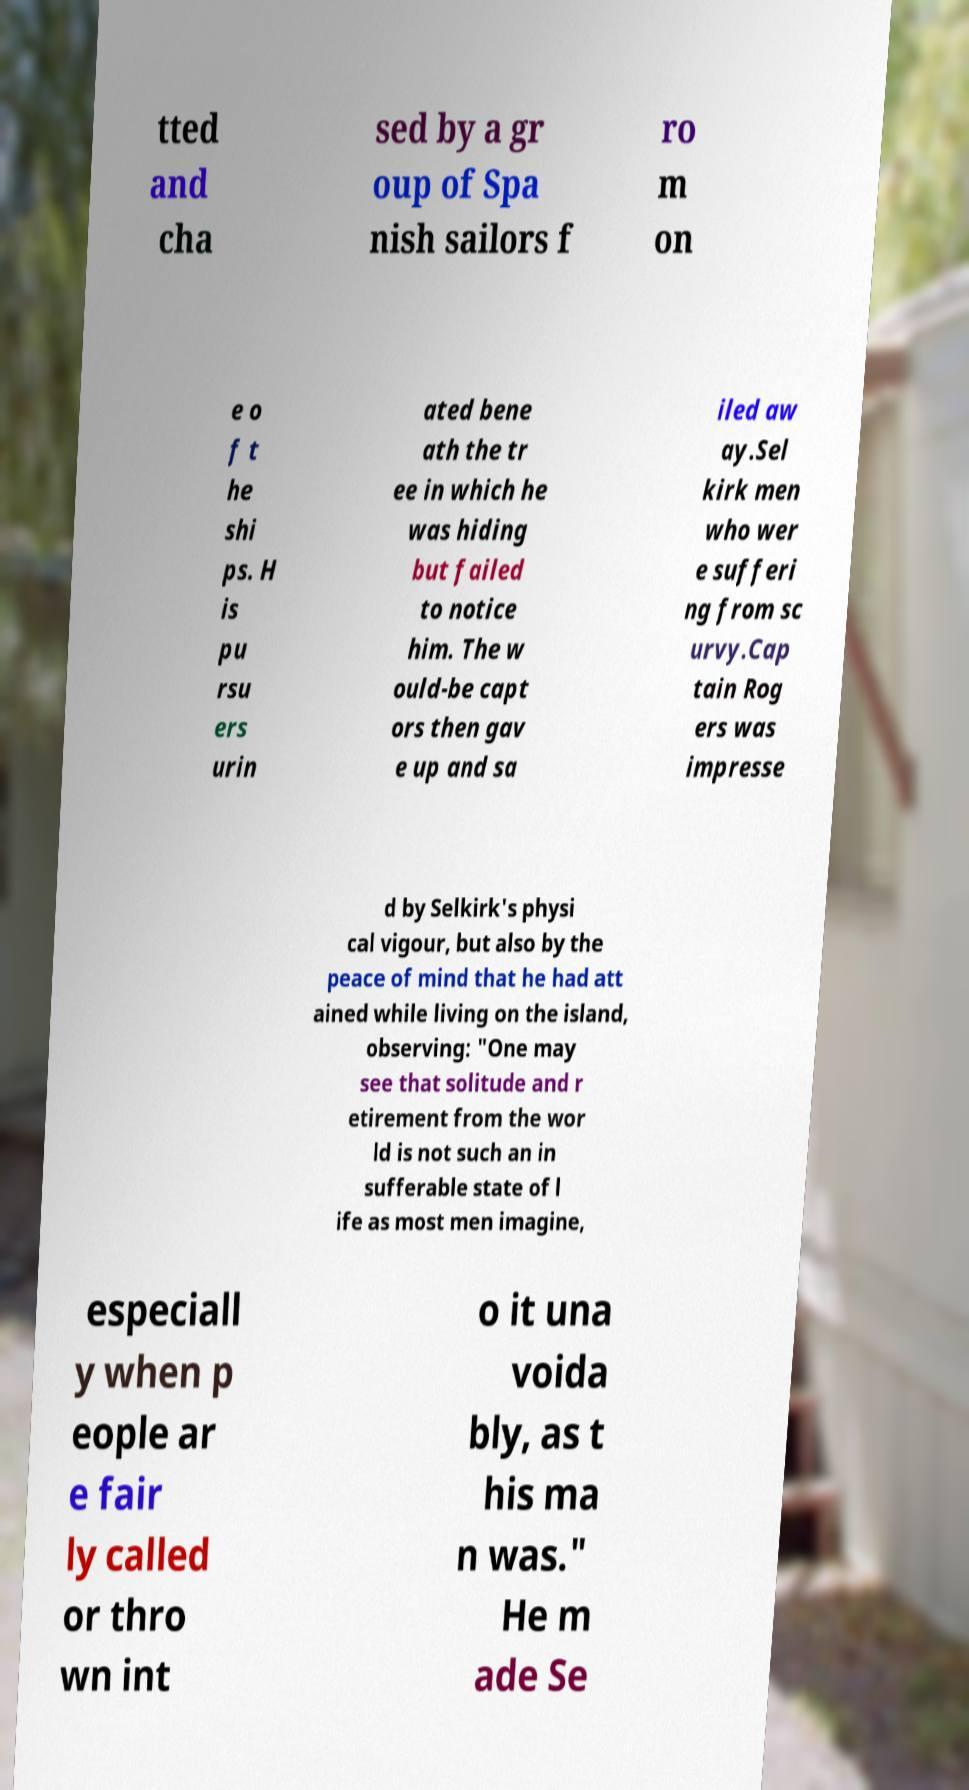For documentation purposes, I need the text within this image transcribed. Could you provide that? tted and cha sed by a gr oup of Spa nish sailors f ro m on e o f t he shi ps. H is pu rsu ers urin ated bene ath the tr ee in which he was hiding but failed to notice him. The w ould-be capt ors then gav e up and sa iled aw ay.Sel kirk men who wer e sufferi ng from sc urvy.Cap tain Rog ers was impresse d by Selkirk's physi cal vigour, but also by the peace of mind that he had att ained while living on the island, observing: "One may see that solitude and r etirement from the wor ld is not such an in sufferable state of l ife as most men imagine, especiall y when p eople ar e fair ly called or thro wn int o it una voida bly, as t his ma n was." He m ade Se 